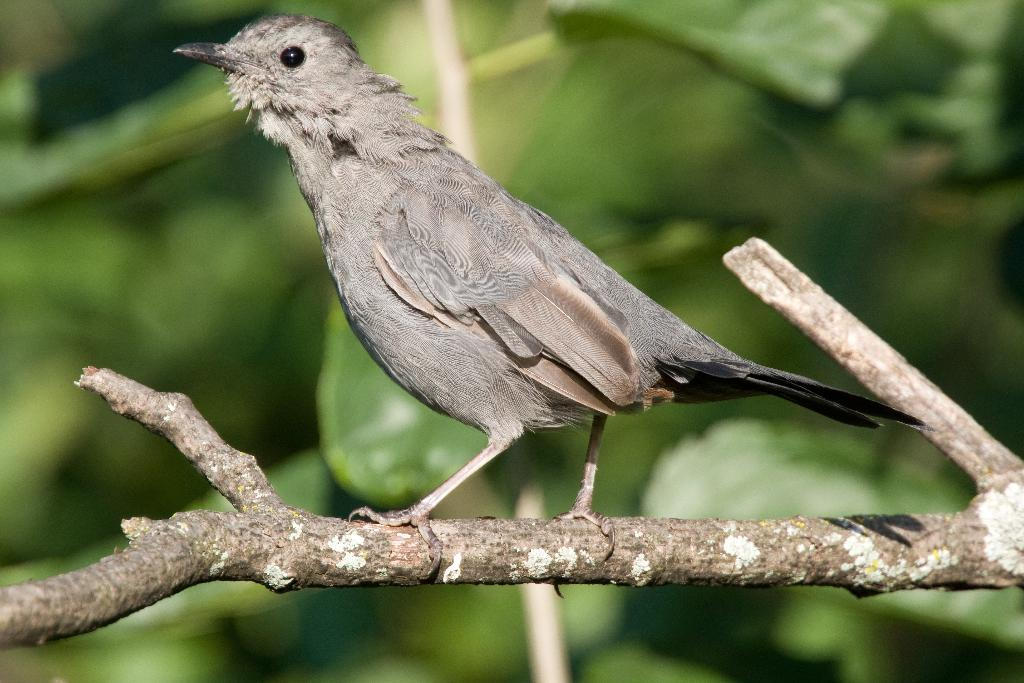What type of animal is in the image? There is a bird in the image. Where is the bird located? The bird is standing on a tree. What colors can be seen on the bird? The bird has brown, grey, and black coloring. What is the condition of the bomb in the image? There is no bomb present in the image; it features a bird standing on a tree. 